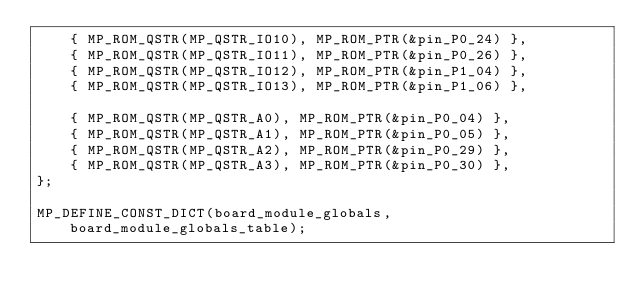<code> <loc_0><loc_0><loc_500><loc_500><_C_>    { MP_ROM_QSTR(MP_QSTR_IO10), MP_ROM_PTR(&pin_P0_24) },
    { MP_ROM_QSTR(MP_QSTR_IO11), MP_ROM_PTR(&pin_P0_26) },
    { MP_ROM_QSTR(MP_QSTR_IO12), MP_ROM_PTR(&pin_P1_04) },
    { MP_ROM_QSTR(MP_QSTR_IO13), MP_ROM_PTR(&pin_P1_06) },

    { MP_ROM_QSTR(MP_QSTR_A0), MP_ROM_PTR(&pin_P0_04) },
    { MP_ROM_QSTR(MP_QSTR_A1), MP_ROM_PTR(&pin_P0_05) },
    { MP_ROM_QSTR(MP_QSTR_A2), MP_ROM_PTR(&pin_P0_29) },
    { MP_ROM_QSTR(MP_QSTR_A3), MP_ROM_PTR(&pin_P0_30) },
};

MP_DEFINE_CONST_DICT(board_module_globals, board_module_globals_table);
</code> 